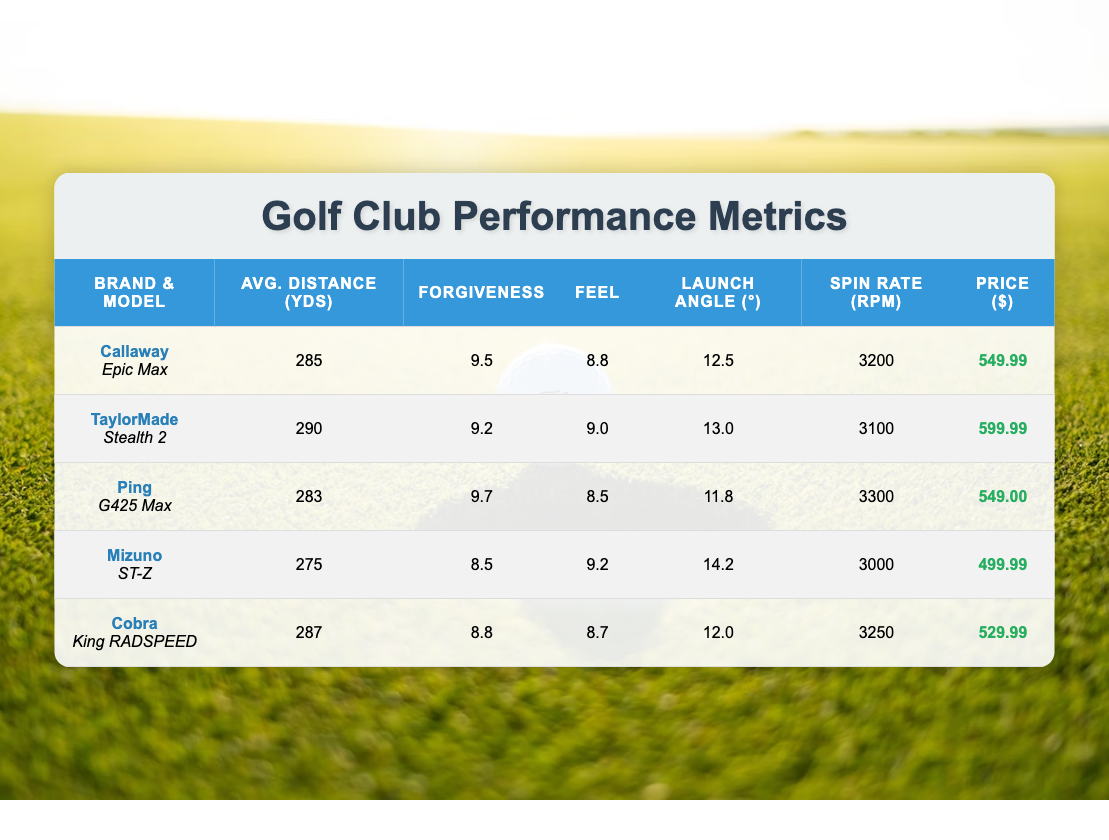What is the average distance of the Callaway Epic Max? The table shows that the average distance for the Callaway Epic Max is listed under "Avg. Distance (yds)" as 285 yards.
Answer: 285 Which golf club has the highest forgiveness rating? By examining the "Forgiveness" column, the highest rating is 9.7, which corresponds to the Ping G425 Max.
Answer: Ping G425 Max What’s the difference in price between the TaylorMade Stealth 2 and the Mizuno ST-Z? The price for the TaylorMade Stealth 2 is 599.99, and the price for the Mizuno ST-Z is 499.99. The difference is calculated as 599.99 - 499.99 = 100.00.
Answer: 100.00 Is the average distance of the Cobra King RADSPEED greater than 280 yards? The Cobra King RADSPEED has an average distance of 287 yards, which is greater than 280 yards. Therefore, the answer is yes.
Answer: Yes Which brand has the lowest feel rating? Looking at the "Feel" ratings in the table, the lowest is 8.5, found with the Ping G425 Max.
Answer: Ping G425 Max What is the average launch angle of the clubs listed in the table? To find the average, sum the launch angles: 12.5 + 13.0 + 11.8 + 14.2 + 12.0 = 63.5. There are 5 clubs, so the average is 63.5 / 5 = 12.7.
Answer: 12.7 Does any golf club have a Forgiveness rating of 8.5? Yes, the Mizuno ST-Z has a forgiveness rating of 8.5, which confirms that there is at least one club with that rating.
Answer: Yes Which club has both a higher average distance and lower spin rate than the Ping G425 Max? The Ping G425 Max has an average distance of 283 yards and a spin rate of 3300 rpm. The club that fits this criterion is the Callaway Epic Max, which has an average distance of 285 yards and a spin rate of 3200 rpm.
Answer: Callaway Epic Max 